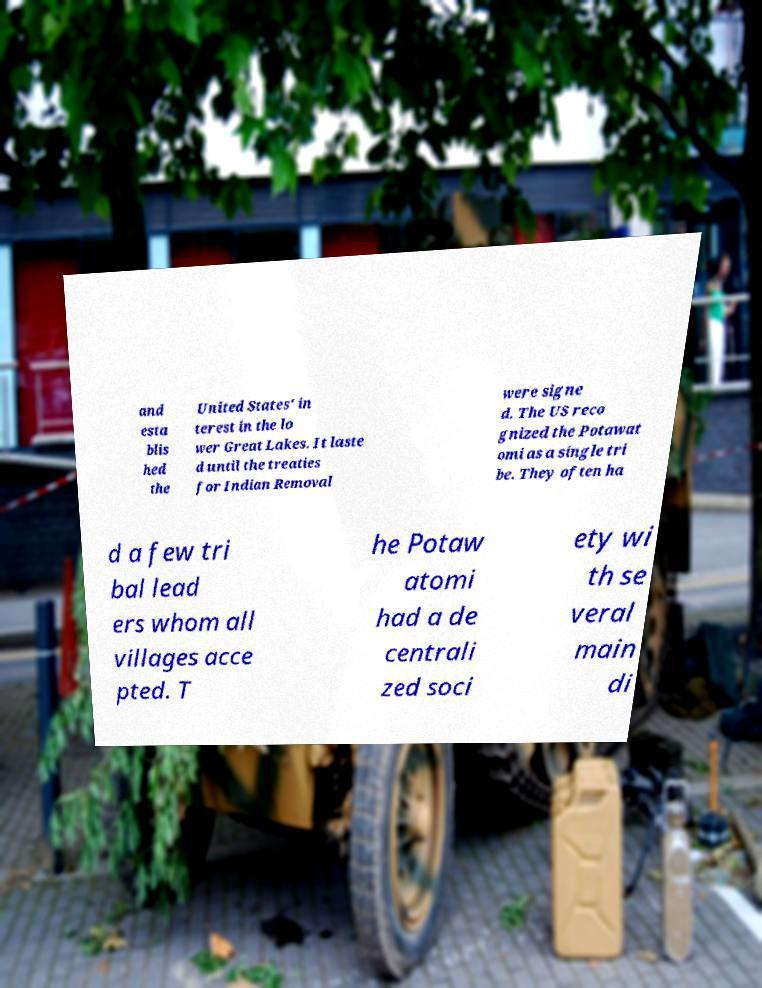For documentation purposes, I need the text within this image transcribed. Could you provide that? and esta blis hed the United States' in terest in the lo wer Great Lakes. It laste d until the treaties for Indian Removal were signe d. The US reco gnized the Potawat omi as a single tri be. They often ha d a few tri bal lead ers whom all villages acce pted. T he Potaw atomi had a de centrali zed soci ety wi th se veral main di 